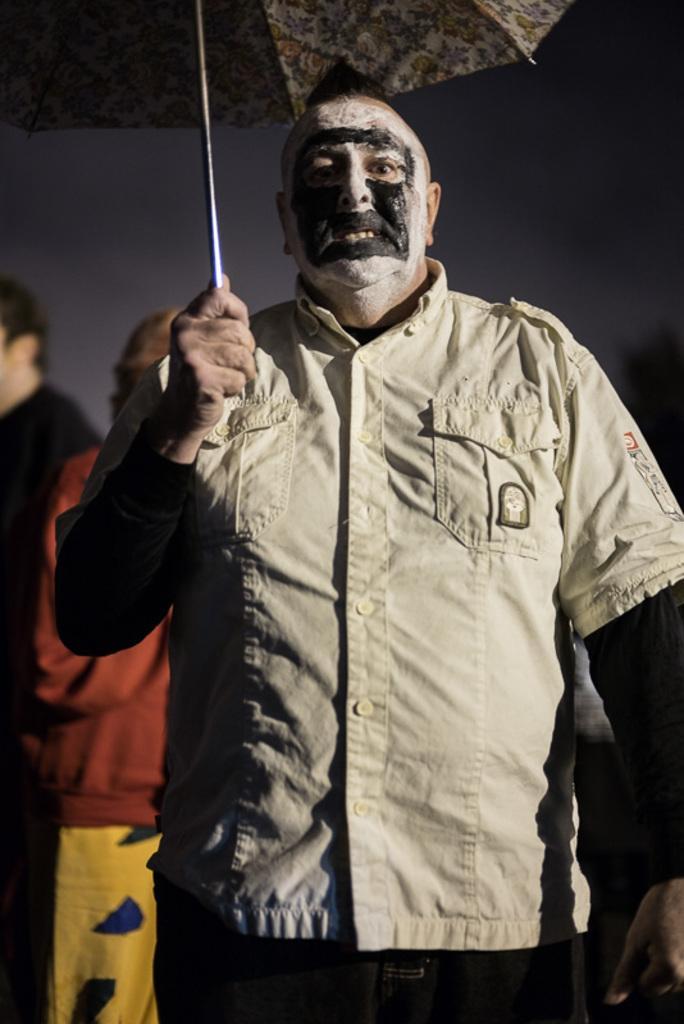Could you give a brief overview of what you see in this image? In this image, we can see persons wearing clothes. There is a person in the middle of the image holding an umbrella with his hand. 